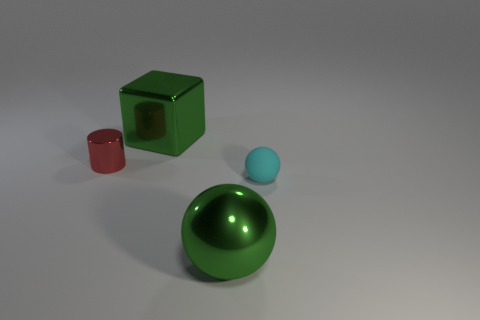Subtract all green balls. How many balls are left? 1 Add 3 cyan rubber things. How many objects exist? 7 Add 2 gray cylinders. How many gray cylinders exist? 2 Subtract 1 cyan spheres. How many objects are left? 3 Subtract all brown balls. Subtract all cyan cubes. How many balls are left? 2 Subtract all green cylinders. How many purple cubes are left? 0 Subtract all tiny red metallic cylinders. Subtract all big green metal objects. How many objects are left? 1 Add 3 cyan spheres. How many cyan spheres are left? 4 